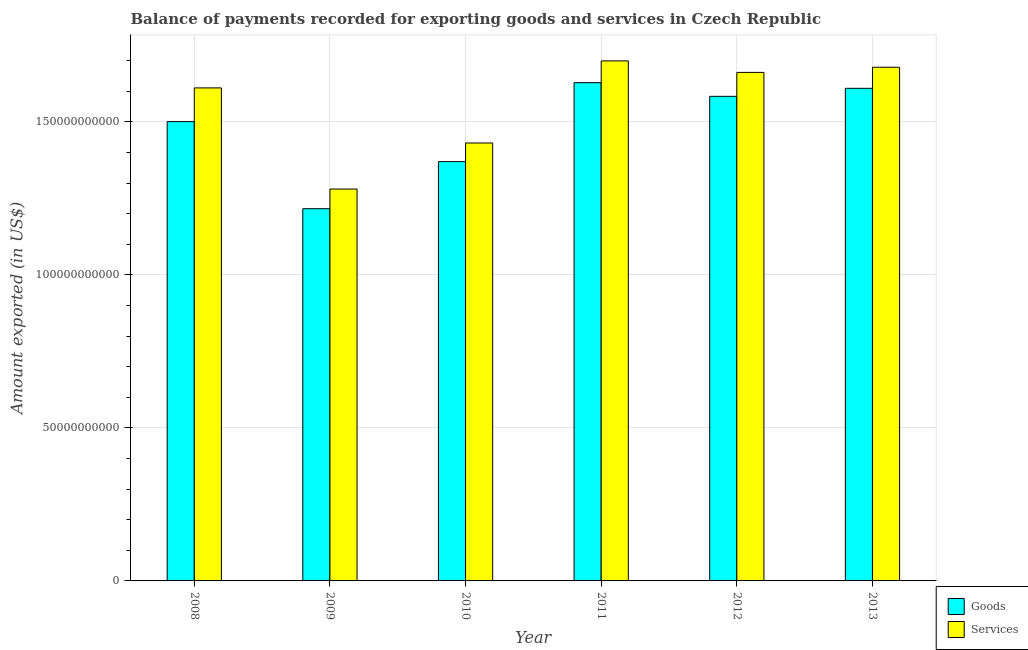How many different coloured bars are there?
Provide a short and direct response. 2. How many groups of bars are there?
Your answer should be compact. 6. Are the number of bars per tick equal to the number of legend labels?
Ensure brevity in your answer.  Yes. How many bars are there on the 6th tick from the right?
Offer a very short reply. 2. In how many cases, is the number of bars for a given year not equal to the number of legend labels?
Your answer should be very brief. 0. What is the amount of services exported in 2009?
Give a very brief answer. 1.28e+11. Across all years, what is the maximum amount of services exported?
Your answer should be compact. 1.70e+11. Across all years, what is the minimum amount of services exported?
Your response must be concise. 1.28e+11. In which year was the amount of services exported minimum?
Offer a very short reply. 2009. What is the total amount of goods exported in the graph?
Your answer should be compact. 8.91e+11. What is the difference between the amount of goods exported in 2010 and that in 2013?
Provide a short and direct response. -2.39e+1. What is the difference between the amount of goods exported in 2011 and the amount of services exported in 2008?
Your answer should be very brief. 1.27e+1. What is the average amount of services exported per year?
Provide a succinct answer. 1.56e+11. What is the ratio of the amount of services exported in 2009 to that in 2011?
Make the answer very short. 0.75. Is the amount of goods exported in 2009 less than that in 2013?
Your answer should be compact. Yes. Is the difference between the amount of goods exported in 2011 and 2013 greater than the difference between the amount of services exported in 2011 and 2013?
Provide a short and direct response. No. What is the difference between the highest and the second highest amount of goods exported?
Provide a succinct answer. 1.84e+09. What is the difference between the highest and the lowest amount of goods exported?
Make the answer very short. 4.12e+1. In how many years, is the amount of services exported greater than the average amount of services exported taken over all years?
Your answer should be very brief. 4. Is the sum of the amount of goods exported in 2010 and 2011 greater than the maximum amount of services exported across all years?
Offer a terse response. Yes. What does the 2nd bar from the left in 2010 represents?
Your answer should be very brief. Services. What does the 1st bar from the right in 2013 represents?
Make the answer very short. Services. How many bars are there?
Ensure brevity in your answer.  12. Are all the bars in the graph horizontal?
Your response must be concise. No. What is the difference between two consecutive major ticks on the Y-axis?
Offer a terse response. 5.00e+1. Are the values on the major ticks of Y-axis written in scientific E-notation?
Make the answer very short. No. Does the graph contain any zero values?
Offer a terse response. No. Where does the legend appear in the graph?
Provide a succinct answer. Bottom right. How many legend labels are there?
Keep it short and to the point. 2. What is the title of the graph?
Provide a succinct answer. Balance of payments recorded for exporting goods and services in Czech Republic. Does "Death rate" appear as one of the legend labels in the graph?
Your answer should be very brief. No. What is the label or title of the X-axis?
Your answer should be very brief. Year. What is the label or title of the Y-axis?
Keep it short and to the point. Amount exported (in US$). What is the Amount exported (in US$) of Goods in 2008?
Your response must be concise. 1.50e+11. What is the Amount exported (in US$) in Services in 2008?
Keep it short and to the point. 1.61e+11. What is the Amount exported (in US$) of Goods in 2009?
Make the answer very short. 1.22e+11. What is the Amount exported (in US$) in Services in 2009?
Offer a terse response. 1.28e+11. What is the Amount exported (in US$) in Goods in 2010?
Make the answer very short. 1.37e+11. What is the Amount exported (in US$) of Services in 2010?
Your answer should be compact. 1.43e+11. What is the Amount exported (in US$) in Goods in 2011?
Your answer should be very brief. 1.63e+11. What is the Amount exported (in US$) of Services in 2011?
Provide a short and direct response. 1.70e+11. What is the Amount exported (in US$) of Goods in 2012?
Keep it short and to the point. 1.58e+11. What is the Amount exported (in US$) of Services in 2012?
Give a very brief answer. 1.66e+11. What is the Amount exported (in US$) of Goods in 2013?
Ensure brevity in your answer.  1.61e+11. What is the Amount exported (in US$) in Services in 2013?
Your answer should be compact. 1.68e+11. Across all years, what is the maximum Amount exported (in US$) in Goods?
Provide a short and direct response. 1.63e+11. Across all years, what is the maximum Amount exported (in US$) in Services?
Make the answer very short. 1.70e+11. Across all years, what is the minimum Amount exported (in US$) in Goods?
Your answer should be compact. 1.22e+11. Across all years, what is the minimum Amount exported (in US$) of Services?
Provide a succinct answer. 1.28e+11. What is the total Amount exported (in US$) in Goods in the graph?
Offer a very short reply. 8.91e+11. What is the total Amount exported (in US$) in Services in the graph?
Offer a terse response. 9.36e+11. What is the difference between the Amount exported (in US$) in Goods in 2008 and that in 2009?
Offer a very short reply. 2.85e+1. What is the difference between the Amount exported (in US$) in Services in 2008 and that in 2009?
Provide a succinct answer. 3.30e+1. What is the difference between the Amount exported (in US$) in Goods in 2008 and that in 2010?
Provide a succinct answer. 1.31e+1. What is the difference between the Amount exported (in US$) in Services in 2008 and that in 2010?
Offer a terse response. 1.80e+1. What is the difference between the Amount exported (in US$) in Goods in 2008 and that in 2011?
Your answer should be compact. -1.27e+1. What is the difference between the Amount exported (in US$) in Services in 2008 and that in 2011?
Provide a short and direct response. -8.83e+09. What is the difference between the Amount exported (in US$) of Goods in 2008 and that in 2012?
Your answer should be very brief. -8.27e+09. What is the difference between the Amount exported (in US$) of Services in 2008 and that in 2012?
Your answer should be very brief. -5.06e+09. What is the difference between the Amount exported (in US$) of Goods in 2008 and that in 2013?
Your response must be concise. -1.09e+1. What is the difference between the Amount exported (in US$) of Services in 2008 and that in 2013?
Your answer should be very brief. -6.75e+09. What is the difference between the Amount exported (in US$) of Goods in 2009 and that in 2010?
Your answer should be compact. -1.54e+1. What is the difference between the Amount exported (in US$) in Services in 2009 and that in 2010?
Your answer should be very brief. -1.50e+1. What is the difference between the Amount exported (in US$) of Goods in 2009 and that in 2011?
Give a very brief answer. -4.12e+1. What is the difference between the Amount exported (in US$) in Services in 2009 and that in 2011?
Your answer should be compact. -4.19e+1. What is the difference between the Amount exported (in US$) of Goods in 2009 and that in 2012?
Make the answer very short. -3.67e+1. What is the difference between the Amount exported (in US$) in Services in 2009 and that in 2012?
Your answer should be compact. -3.81e+1. What is the difference between the Amount exported (in US$) of Goods in 2009 and that in 2013?
Your response must be concise. -3.93e+1. What is the difference between the Amount exported (in US$) in Services in 2009 and that in 2013?
Your response must be concise. -3.98e+1. What is the difference between the Amount exported (in US$) in Goods in 2010 and that in 2011?
Provide a short and direct response. -2.58e+1. What is the difference between the Amount exported (in US$) in Services in 2010 and that in 2011?
Offer a very short reply. -2.68e+1. What is the difference between the Amount exported (in US$) of Goods in 2010 and that in 2012?
Give a very brief answer. -2.13e+1. What is the difference between the Amount exported (in US$) in Services in 2010 and that in 2012?
Keep it short and to the point. -2.31e+1. What is the difference between the Amount exported (in US$) of Goods in 2010 and that in 2013?
Your answer should be very brief. -2.39e+1. What is the difference between the Amount exported (in US$) in Services in 2010 and that in 2013?
Give a very brief answer. -2.48e+1. What is the difference between the Amount exported (in US$) in Goods in 2011 and that in 2012?
Keep it short and to the point. 4.46e+09. What is the difference between the Amount exported (in US$) in Services in 2011 and that in 2012?
Provide a succinct answer. 3.76e+09. What is the difference between the Amount exported (in US$) of Goods in 2011 and that in 2013?
Give a very brief answer. 1.84e+09. What is the difference between the Amount exported (in US$) in Services in 2011 and that in 2013?
Your response must be concise. 2.08e+09. What is the difference between the Amount exported (in US$) in Goods in 2012 and that in 2013?
Ensure brevity in your answer.  -2.62e+09. What is the difference between the Amount exported (in US$) of Services in 2012 and that in 2013?
Your response must be concise. -1.69e+09. What is the difference between the Amount exported (in US$) in Goods in 2008 and the Amount exported (in US$) in Services in 2009?
Ensure brevity in your answer.  2.20e+1. What is the difference between the Amount exported (in US$) in Goods in 2008 and the Amount exported (in US$) in Services in 2010?
Your response must be concise. 6.98e+09. What is the difference between the Amount exported (in US$) in Goods in 2008 and the Amount exported (in US$) in Services in 2011?
Give a very brief answer. -1.99e+1. What is the difference between the Amount exported (in US$) in Goods in 2008 and the Amount exported (in US$) in Services in 2012?
Your answer should be compact. -1.61e+1. What is the difference between the Amount exported (in US$) of Goods in 2008 and the Amount exported (in US$) of Services in 2013?
Your answer should be very brief. -1.78e+1. What is the difference between the Amount exported (in US$) of Goods in 2009 and the Amount exported (in US$) of Services in 2010?
Make the answer very short. -2.15e+1. What is the difference between the Amount exported (in US$) of Goods in 2009 and the Amount exported (in US$) of Services in 2011?
Your answer should be very brief. -4.83e+1. What is the difference between the Amount exported (in US$) in Goods in 2009 and the Amount exported (in US$) in Services in 2012?
Offer a terse response. -4.45e+1. What is the difference between the Amount exported (in US$) in Goods in 2009 and the Amount exported (in US$) in Services in 2013?
Your response must be concise. -4.62e+1. What is the difference between the Amount exported (in US$) of Goods in 2010 and the Amount exported (in US$) of Services in 2011?
Ensure brevity in your answer.  -3.29e+1. What is the difference between the Amount exported (in US$) in Goods in 2010 and the Amount exported (in US$) in Services in 2012?
Provide a succinct answer. -2.92e+1. What is the difference between the Amount exported (in US$) in Goods in 2010 and the Amount exported (in US$) in Services in 2013?
Your answer should be very brief. -3.08e+1. What is the difference between the Amount exported (in US$) of Goods in 2011 and the Amount exported (in US$) of Services in 2012?
Offer a very short reply. -3.36e+09. What is the difference between the Amount exported (in US$) of Goods in 2011 and the Amount exported (in US$) of Services in 2013?
Offer a terse response. -5.05e+09. What is the difference between the Amount exported (in US$) of Goods in 2012 and the Amount exported (in US$) of Services in 2013?
Your answer should be compact. -9.51e+09. What is the average Amount exported (in US$) in Goods per year?
Offer a terse response. 1.48e+11. What is the average Amount exported (in US$) in Services per year?
Provide a short and direct response. 1.56e+11. In the year 2008, what is the difference between the Amount exported (in US$) in Goods and Amount exported (in US$) in Services?
Your answer should be compact. -1.10e+1. In the year 2009, what is the difference between the Amount exported (in US$) of Goods and Amount exported (in US$) of Services?
Make the answer very short. -6.44e+09. In the year 2010, what is the difference between the Amount exported (in US$) of Goods and Amount exported (in US$) of Services?
Provide a short and direct response. -6.08e+09. In the year 2011, what is the difference between the Amount exported (in US$) in Goods and Amount exported (in US$) in Services?
Make the answer very short. -7.13e+09. In the year 2012, what is the difference between the Amount exported (in US$) in Goods and Amount exported (in US$) in Services?
Offer a very short reply. -7.82e+09. In the year 2013, what is the difference between the Amount exported (in US$) in Goods and Amount exported (in US$) in Services?
Offer a very short reply. -6.89e+09. What is the ratio of the Amount exported (in US$) of Goods in 2008 to that in 2009?
Provide a short and direct response. 1.23. What is the ratio of the Amount exported (in US$) in Services in 2008 to that in 2009?
Your answer should be compact. 1.26. What is the ratio of the Amount exported (in US$) of Goods in 2008 to that in 2010?
Provide a short and direct response. 1.1. What is the ratio of the Amount exported (in US$) of Services in 2008 to that in 2010?
Offer a terse response. 1.13. What is the ratio of the Amount exported (in US$) of Goods in 2008 to that in 2011?
Ensure brevity in your answer.  0.92. What is the ratio of the Amount exported (in US$) of Services in 2008 to that in 2011?
Ensure brevity in your answer.  0.95. What is the ratio of the Amount exported (in US$) of Goods in 2008 to that in 2012?
Offer a terse response. 0.95. What is the ratio of the Amount exported (in US$) in Services in 2008 to that in 2012?
Give a very brief answer. 0.97. What is the ratio of the Amount exported (in US$) of Goods in 2008 to that in 2013?
Offer a very short reply. 0.93. What is the ratio of the Amount exported (in US$) of Services in 2008 to that in 2013?
Make the answer very short. 0.96. What is the ratio of the Amount exported (in US$) in Goods in 2009 to that in 2010?
Offer a very short reply. 0.89. What is the ratio of the Amount exported (in US$) in Services in 2009 to that in 2010?
Give a very brief answer. 0.89. What is the ratio of the Amount exported (in US$) in Goods in 2009 to that in 2011?
Your answer should be compact. 0.75. What is the ratio of the Amount exported (in US$) of Services in 2009 to that in 2011?
Provide a short and direct response. 0.75. What is the ratio of the Amount exported (in US$) of Goods in 2009 to that in 2012?
Your answer should be compact. 0.77. What is the ratio of the Amount exported (in US$) in Services in 2009 to that in 2012?
Your answer should be very brief. 0.77. What is the ratio of the Amount exported (in US$) of Goods in 2009 to that in 2013?
Provide a short and direct response. 0.76. What is the ratio of the Amount exported (in US$) of Services in 2009 to that in 2013?
Your response must be concise. 0.76. What is the ratio of the Amount exported (in US$) in Goods in 2010 to that in 2011?
Your response must be concise. 0.84. What is the ratio of the Amount exported (in US$) in Services in 2010 to that in 2011?
Your response must be concise. 0.84. What is the ratio of the Amount exported (in US$) of Goods in 2010 to that in 2012?
Your answer should be very brief. 0.87. What is the ratio of the Amount exported (in US$) of Services in 2010 to that in 2012?
Offer a terse response. 0.86. What is the ratio of the Amount exported (in US$) of Goods in 2010 to that in 2013?
Give a very brief answer. 0.85. What is the ratio of the Amount exported (in US$) in Services in 2010 to that in 2013?
Provide a succinct answer. 0.85. What is the ratio of the Amount exported (in US$) of Goods in 2011 to that in 2012?
Offer a terse response. 1.03. What is the ratio of the Amount exported (in US$) in Services in 2011 to that in 2012?
Offer a terse response. 1.02. What is the ratio of the Amount exported (in US$) of Goods in 2011 to that in 2013?
Provide a short and direct response. 1.01. What is the ratio of the Amount exported (in US$) of Services in 2011 to that in 2013?
Ensure brevity in your answer.  1.01. What is the ratio of the Amount exported (in US$) of Goods in 2012 to that in 2013?
Make the answer very short. 0.98. What is the ratio of the Amount exported (in US$) in Services in 2012 to that in 2013?
Offer a very short reply. 0.99. What is the difference between the highest and the second highest Amount exported (in US$) in Goods?
Ensure brevity in your answer.  1.84e+09. What is the difference between the highest and the second highest Amount exported (in US$) in Services?
Offer a terse response. 2.08e+09. What is the difference between the highest and the lowest Amount exported (in US$) of Goods?
Your answer should be very brief. 4.12e+1. What is the difference between the highest and the lowest Amount exported (in US$) in Services?
Ensure brevity in your answer.  4.19e+1. 